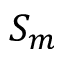<formula> <loc_0><loc_0><loc_500><loc_500>S _ { m }</formula> 